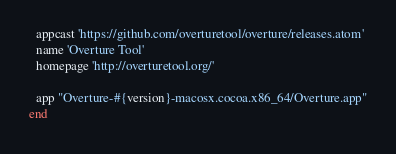Convert code to text. <code><loc_0><loc_0><loc_500><loc_500><_Ruby_>  appcast 'https://github.com/overturetool/overture/releases.atom'
  name 'Overture Tool'
  homepage 'http://overturetool.org/'

  app "Overture-#{version}-macosx.cocoa.x86_64/Overture.app"
end
</code> 